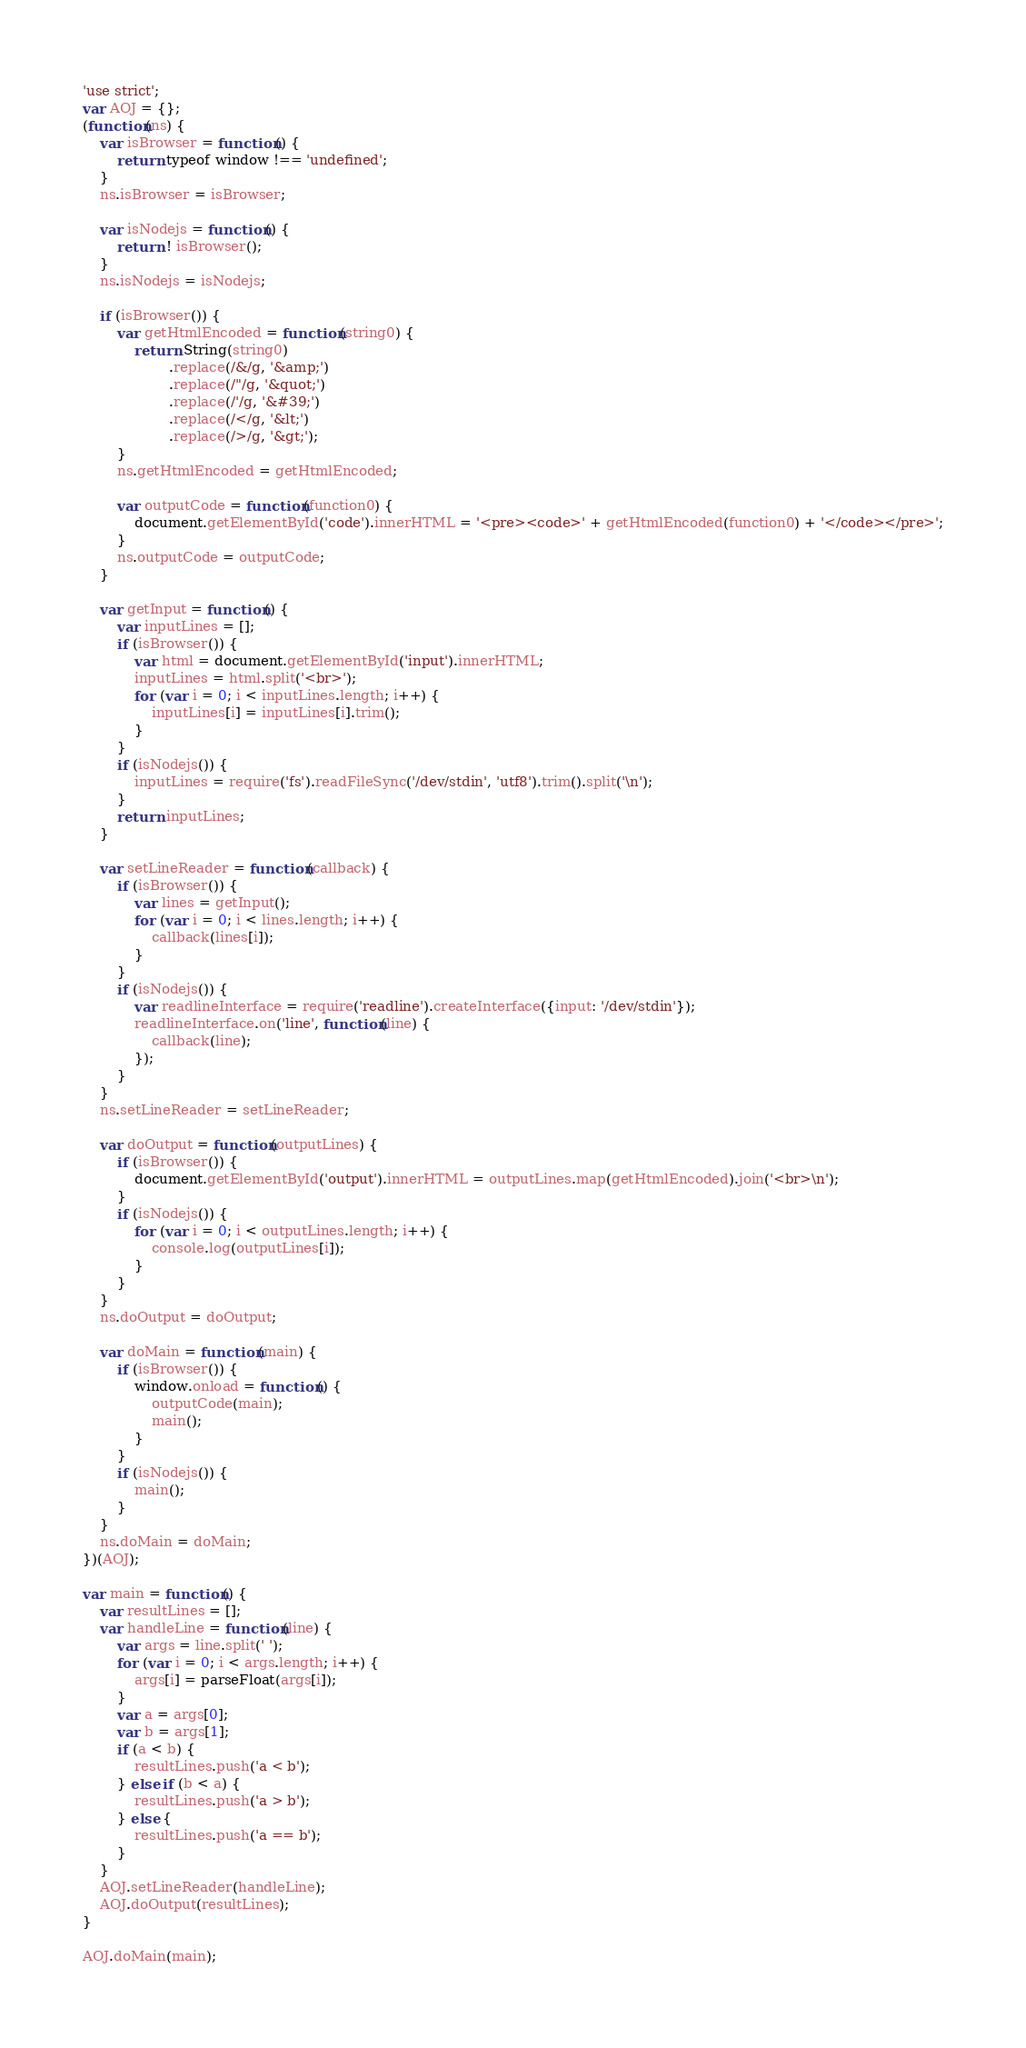Convert code to text. <code><loc_0><loc_0><loc_500><loc_500><_JavaScript_>'use strict';
var AOJ = {};
(function(ns) {
    var isBrowser = function() {
        return typeof window !== 'undefined';
    }
    ns.isBrowser = isBrowser;
    
    var isNodejs = function() {
        return ! isBrowser();
    }
    ns.isNodejs = isNodejs;
    
    if (isBrowser()) {
        var getHtmlEncoded = function(string0) {
            return String(string0)
                    .replace(/&/g, '&amp;')
                    .replace(/"/g, '&quot;')
                    .replace(/'/g, '&#39;')
                    .replace(/</g, '&lt;')
                    .replace(/>/g, '&gt;');
        }
        ns.getHtmlEncoded = getHtmlEncoded;
        
        var outputCode = function(function0) {
            document.getElementById('code').innerHTML = '<pre><code>' + getHtmlEncoded(function0) + '</code></pre>';
        }
        ns.outputCode = outputCode;
    }
    
    var getInput = function() {
        var inputLines = [];
        if (isBrowser()) {
            var html = document.getElementById('input').innerHTML;
            inputLines = html.split('<br>');
            for (var i = 0; i < inputLines.length; i++) {
                inputLines[i] = inputLines[i].trim();
            }
        }
        if (isNodejs()) {
            inputLines = require('fs').readFileSync('/dev/stdin', 'utf8').trim().split('\n');
        }
        return inputLines;
    }
    
    var setLineReader = function(callback) {
        if (isBrowser()) {
            var lines = getInput();
            for (var i = 0; i < lines.length; i++) {
                callback(lines[i]);
            }
        }
        if (isNodejs()) {
            var readlineInterface = require('readline').createInterface({input: '/dev/stdin'});
            readlineInterface.on('line', function(line) {
                callback(line);
            });
        }
    }
    ns.setLineReader = setLineReader;
    
    var doOutput = function(outputLines) {
        if (isBrowser()) {
            document.getElementById('output').innerHTML = outputLines.map(getHtmlEncoded).join('<br>\n');
        }
        if (isNodejs()) {
            for (var i = 0; i < outputLines.length; i++) {
                console.log(outputLines[i]);
            }
        }
    }
    ns.doOutput = doOutput;
    
    var doMain = function(main) {
        if (isBrowser()) {
            window.onload = function() {
                outputCode(main);
                main();
            }
        }
        if (isNodejs()) {
            main();
        }
    }
    ns.doMain = doMain;
})(AOJ);

var main = function() {
    var resultLines = [];
    var handleLine = function(line) {
        var args = line.split(' ');
        for (var i = 0; i < args.length; i++) {
            args[i] = parseFloat(args[i]);
        }
        var a = args[0];
        var b = args[1];
        if (a < b) {
            resultLines.push('a < b');
        } else if (b < a) {
            resultLines.push('a > b');
        } else {
            resultLines.push('a == b');
        }
    }
    AOJ.setLineReader(handleLine);
    AOJ.doOutput(resultLines);
}

AOJ.doMain(main);</code> 